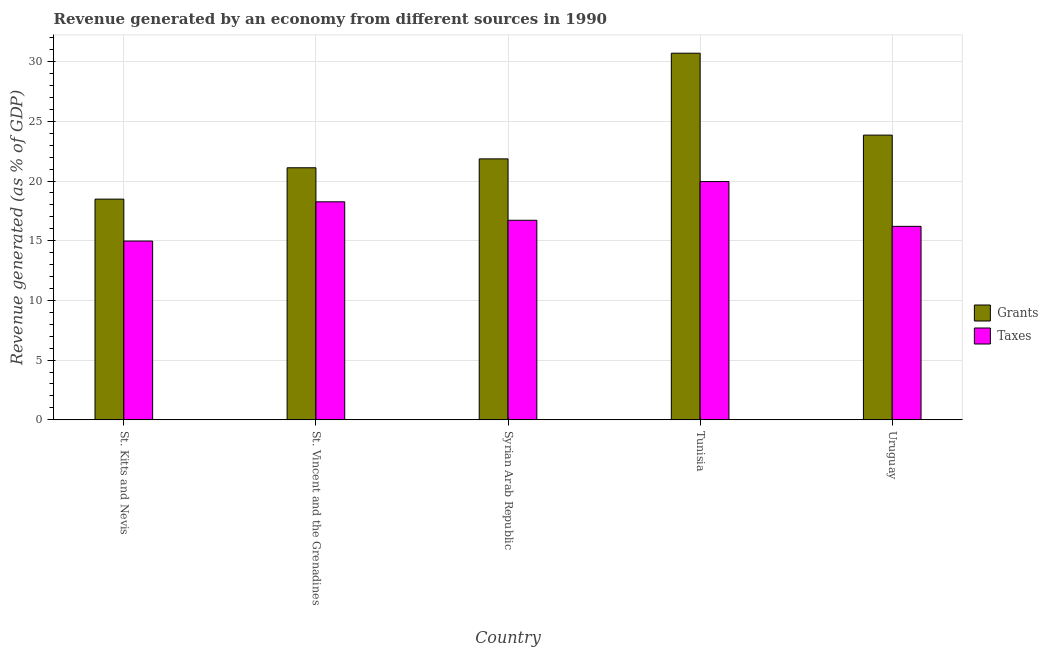How many different coloured bars are there?
Your response must be concise. 2. How many groups of bars are there?
Keep it short and to the point. 5. Are the number of bars per tick equal to the number of legend labels?
Provide a short and direct response. Yes. Are the number of bars on each tick of the X-axis equal?
Provide a short and direct response. Yes. What is the label of the 2nd group of bars from the left?
Make the answer very short. St. Vincent and the Grenadines. In how many cases, is the number of bars for a given country not equal to the number of legend labels?
Keep it short and to the point. 0. What is the revenue generated by grants in Syrian Arab Republic?
Provide a short and direct response. 21.85. Across all countries, what is the maximum revenue generated by taxes?
Provide a succinct answer. 19.95. Across all countries, what is the minimum revenue generated by grants?
Keep it short and to the point. 18.48. In which country was the revenue generated by grants maximum?
Provide a short and direct response. Tunisia. In which country was the revenue generated by taxes minimum?
Your response must be concise. St. Kitts and Nevis. What is the total revenue generated by taxes in the graph?
Provide a short and direct response. 86.1. What is the difference between the revenue generated by grants in Syrian Arab Republic and that in Uruguay?
Provide a succinct answer. -1.99. What is the difference between the revenue generated by grants in St. Vincent and the Grenadines and the revenue generated by taxes in Tunisia?
Make the answer very short. 1.16. What is the average revenue generated by taxes per country?
Make the answer very short. 17.22. What is the difference between the revenue generated by taxes and revenue generated by grants in St. Kitts and Nevis?
Provide a succinct answer. -3.51. What is the ratio of the revenue generated by taxes in Syrian Arab Republic to that in Uruguay?
Offer a terse response. 1.03. What is the difference between the highest and the second highest revenue generated by taxes?
Provide a short and direct response. 1.69. What is the difference between the highest and the lowest revenue generated by taxes?
Offer a terse response. 4.98. In how many countries, is the revenue generated by grants greater than the average revenue generated by grants taken over all countries?
Give a very brief answer. 2. Is the sum of the revenue generated by grants in Syrian Arab Republic and Tunisia greater than the maximum revenue generated by taxes across all countries?
Offer a terse response. Yes. What does the 2nd bar from the left in Uruguay represents?
Offer a terse response. Taxes. What does the 1st bar from the right in St. Kitts and Nevis represents?
Give a very brief answer. Taxes. How many bars are there?
Offer a very short reply. 10. Are all the bars in the graph horizontal?
Keep it short and to the point. No. How many countries are there in the graph?
Keep it short and to the point. 5. What is the difference between two consecutive major ticks on the Y-axis?
Provide a short and direct response. 5. Where does the legend appear in the graph?
Make the answer very short. Center right. How many legend labels are there?
Keep it short and to the point. 2. How are the legend labels stacked?
Keep it short and to the point. Vertical. What is the title of the graph?
Your answer should be compact. Revenue generated by an economy from different sources in 1990. What is the label or title of the X-axis?
Offer a terse response. Country. What is the label or title of the Y-axis?
Offer a terse response. Revenue generated (as % of GDP). What is the Revenue generated (as % of GDP) of Grants in St. Kitts and Nevis?
Your answer should be compact. 18.48. What is the Revenue generated (as % of GDP) of Taxes in St. Kitts and Nevis?
Keep it short and to the point. 14.97. What is the Revenue generated (as % of GDP) of Grants in St. Vincent and the Grenadines?
Keep it short and to the point. 21.11. What is the Revenue generated (as % of GDP) in Taxes in St. Vincent and the Grenadines?
Your answer should be very brief. 18.26. What is the Revenue generated (as % of GDP) in Grants in Syrian Arab Republic?
Provide a short and direct response. 21.85. What is the Revenue generated (as % of GDP) of Taxes in Syrian Arab Republic?
Your response must be concise. 16.71. What is the Revenue generated (as % of GDP) in Grants in Tunisia?
Provide a succinct answer. 30.71. What is the Revenue generated (as % of GDP) in Taxes in Tunisia?
Provide a succinct answer. 19.95. What is the Revenue generated (as % of GDP) of Grants in Uruguay?
Make the answer very short. 23.84. What is the Revenue generated (as % of GDP) in Taxes in Uruguay?
Your answer should be compact. 16.2. Across all countries, what is the maximum Revenue generated (as % of GDP) of Grants?
Your response must be concise. 30.71. Across all countries, what is the maximum Revenue generated (as % of GDP) of Taxes?
Provide a short and direct response. 19.95. Across all countries, what is the minimum Revenue generated (as % of GDP) of Grants?
Your answer should be very brief. 18.48. Across all countries, what is the minimum Revenue generated (as % of GDP) in Taxes?
Give a very brief answer. 14.97. What is the total Revenue generated (as % of GDP) of Grants in the graph?
Your answer should be compact. 116. What is the total Revenue generated (as % of GDP) in Taxes in the graph?
Keep it short and to the point. 86.1. What is the difference between the Revenue generated (as % of GDP) in Grants in St. Kitts and Nevis and that in St. Vincent and the Grenadines?
Give a very brief answer. -2.63. What is the difference between the Revenue generated (as % of GDP) in Taxes in St. Kitts and Nevis and that in St. Vincent and the Grenadines?
Provide a short and direct response. -3.29. What is the difference between the Revenue generated (as % of GDP) in Grants in St. Kitts and Nevis and that in Syrian Arab Republic?
Your answer should be very brief. -3.37. What is the difference between the Revenue generated (as % of GDP) in Taxes in St. Kitts and Nevis and that in Syrian Arab Republic?
Make the answer very short. -1.74. What is the difference between the Revenue generated (as % of GDP) in Grants in St. Kitts and Nevis and that in Tunisia?
Your answer should be very brief. -12.22. What is the difference between the Revenue generated (as % of GDP) of Taxes in St. Kitts and Nevis and that in Tunisia?
Your answer should be very brief. -4.98. What is the difference between the Revenue generated (as % of GDP) in Grants in St. Kitts and Nevis and that in Uruguay?
Your answer should be compact. -5.36. What is the difference between the Revenue generated (as % of GDP) in Taxes in St. Kitts and Nevis and that in Uruguay?
Your response must be concise. -1.23. What is the difference between the Revenue generated (as % of GDP) of Grants in St. Vincent and the Grenadines and that in Syrian Arab Republic?
Make the answer very short. -0.74. What is the difference between the Revenue generated (as % of GDP) of Taxes in St. Vincent and the Grenadines and that in Syrian Arab Republic?
Ensure brevity in your answer.  1.55. What is the difference between the Revenue generated (as % of GDP) of Grants in St. Vincent and the Grenadines and that in Tunisia?
Give a very brief answer. -9.6. What is the difference between the Revenue generated (as % of GDP) of Taxes in St. Vincent and the Grenadines and that in Tunisia?
Offer a terse response. -1.69. What is the difference between the Revenue generated (as % of GDP) of Grants in St. Vincent and the Grenadines and that in Uruguay?
Ensure brevity in your answer.  -2.73. What is the difference between the Revenue generated (as % of GDP) of Taxes in St. Vincent and the Grenadines and that in Uruguay?
Your answer should be very brief. 2.06. What is the difference between the Revenue generated (as % of GDP) in Grants in Syrian Arab Republic and that in Tunisia?
Make the answer very short. -8.85. What is the difference between the Revenue generated (as % of GDP) in Taxes in Syrian Arab Republic and that in Tunisia?
Make the answer very short. -3.24. What is the difference between the Revenue generated (as % of GDP) of Grants in Syrian Arab Republic and that in Uruguay?
Offer a very short reply. -1.99. What is the difference between the Revenue generated (as % of GDP) in Taxes in Syrian Arab Republic and that in Uruguay?
Your answer should be very brief. 0.51. What is the difference between the Revenue generated (as % of GDP) in Grants in Tunisia and that in Uruguay?
Your answer should be very brief. 6.86. What is the difference between the Revenue generated (as % of GDP) of Taxes in Tunisia and that in Uruguay?
Your response must be concise. 3.75. What is the difference between the Revenue generated (as % of GDP) of Grants in St. Kitts and Nevis and the Revenue generated (as % of GDP) of Taxes in St. Vincent and the Grenadines?
Offer a very short reply. 0.22. What is the difference between the Revenue generated (as % of GDP) of Grants in St. Kitts and Nevis and the Revenue generated (as % of GDP) of Taxes in Syrian Arab Republic?
Give a very brief answer. 1.77. What is the difference between the Revenue generated (as % of GDP) of Grants in St. Kitts and Nevis and the Revenue generated (as % of GDP) of Taxes in Tunisia?
Your response must be concise. -1.47. What is the difference between the Revenue generated (as % of GDP) in Grants in St. Kitts and Nevis and the Revenue generated (as % of GDP) in Taxes in Uruguay?
Keep it short and to the point. 2.28. What is the difference between the Revenue generated (as % of GDP) of Grants in St. Vincent and the Grenadines and the Revenue generated (as % of GDP) of Taxes in Syrian Arab Republic?
Offer a terse response. 4.4. What is the difference between the Revenue generated (as % of GDP) of Grants in St. Vincent and the Grenadines and the Revenue generated (as % of GDP) of Taxes in Tunisia?
Your answer should be very brief. 1.16. What is the difference between the Revenue generated (as % of GDP) of Grants in St. Vincent and the Grenadines and the Revenue generated (as % of GDP) of Taxes in Uruguay?
Your answer should be very brief. 4.91. What is the difference between the Revenue generated (as % of GDP) of Grants in Syrian Arab Republic and the Revenue generated (as % of GDP) of Taxes in Tunisia?
Offer a very short reply. 1.9. What is the difference between the Revenue generated (as % of GDP) of Grants in Syrian Arab Republic and the Revenue generated (as % of GDP) of Taxes in Uruguay?
Provide a succinct answer. 5.65. What is the difference between the Revenue generated (as % of GDP) of Grants in Tunisia and the Revenue generated (as % of GDP) of Taxes in Uruguay?
Your answer should be compact. 14.5. What is the average Revenue generated (as % of GDP) in Grants per country?
Make the answer very short. 23.2. What is the average Revenue generated (as % of GDP) in Taxes per country?
Your answer should be very brief. 17.22. What is the difference between the Revenue generated (as % of GDP) in Grants and Revenue generated (as % of GDP) in Taxes in St. Kitts and Nevis?
Your answer should be very brief. 3.51. What is the difference between the Revenue generated (as % of GDP) of Grants and Revenue generated (as % of GDP) of Taxes in St. Vincent and the Grenadines?
Provide a succinct answer. 2.85. What is the difference between the Revenue generated (as % of GDP) in Grants and Revenue generated (as % of GDP) in Taxes in Syrian Arab Republic?
Your answer should be compact. 5.14. What is the difference between the Revenue generated (as % of GDP) of Grants and Revenue generated (as % of GDP) of Taxes in Tunisia?
Offer a very short reply. 10.75. What is the difference between the Revenue generated (as % of GDP) of Grants and Revenue generated (as % of GDP) of Taxes in Uruguay?
Provide a succinct answer. 7.64. What is the ratio of the Revenue generated (as % of GDP) in Grants in St. Kitts and Nevis to that in St. Vincent and the Grenadines?
Keep it short and to the point. 0.88. What is the ratio of the Revenue generated (as % of GDP) of Taxes in St. Kitts and Nevis to that in St. Vincent and the Grenadines?
Offer a terse response. 0.82. What is the ratio of the Revenue generated (as % of GDP) of Grants in St. Kitts and Nevis to that in Syrian Arab Republic?
Your answer should be compact. 0.85. What is the ratio of the Revenue generated (as % of GDP) of Taxes in St. Kitts and Nevis to that in Syrian Arab Republic?
Offer a very short reply. 0.9. What is the ratio of the Revenue generated (as % of GDP) of Grants in St. Kitts and Nevis to that in Tunisia?
Provide a succinct answer. 0.6. What is the ratio of the Revenue generated (as % of GDP) of Taxes in St. Kitts and Nevis to that in Tunisia?
Provide a short and direct response. 0.75. What is the ratio of the Revenue generated (as % of GDP) in Grants in St. Kitts and Nevis to that in Uruguay?
Your answer should be very brief. 0.78. What is the ratio of the Revenue generated (as % of GDP) of Taxes in St. Kitts and Nevis to that in Uruguay?
Keep it short and to the point. 0.92. What is the ratio of the Revenue generated (as % of GDP) in Taxes in St. Vincent and the Grenadines to that in Syrian Arab Republic?
Offer a very short reply. 1.09. What is the ratio of the Revenue generated (as % of GDP) in Grants in St. Vincent and the Grenadines to that in Tunisia?
Keep it short and to the point. 0.69. What is the ratio of the Revenue generated (as % of GDP) in Taxes in St. Vincent and the Grenadines to that in Tunisia?
Offer a very short reply. 0.92. What is the ratio of the Revenue generated (as % of GDP) in Grants in St. Vincent and the Grenadines to that in Uruguay?
Keep it short and to the point. 0.89. What is the ratio of the Revenue generated (as % of GDP) of Taxes in St. Vincent and the Grenadines to that in Uruguay?
Offer a very short reply. 1.13. What is the ratio of the Revenue generated (as % of GDP) in Grants in Syrian Arab Republic to that in Tunisia?
Make the answer very short. 0.71. What is the ratio of the Revenue generated (as % of GDP) of Taxes in Syrian Arab Republic to that in Tunisia?
Your response must be concise. 0.84. What is the ratio of the Revenue generated (as % of GDP) of Grants in Syrian Arab Republic to that in Uruguay?
Provide a succinct answer. 0.92. What is the ratio of the Revenue generated (as % of GDP) of Taxes in Syrian Arab Republic to that in Uruguay?
Provide a succinct answer. 1.03. What is the ratio of the Revenue generated (as % of GDP) in Grants in Tunisia to that in Uruguay?
Your answer should be very brief. 1.29. What is the ratio of the Revenue generated (as % of GDP) in Taxes in Tunisia to that in Uruguay?
Offer a terse response. 1.23. What is the difference between the highest and the second highest Revenue generated (as % of GDP) in Grants?
Your answer should be compact. 6.86. What is the difference between the highest and the second highest Revenue generated (as % of GDP) of Taxes?
Your answer should be very brief. 1.69. What is the difference between the highest and the lowest Revenue generated (as % of GDP) in Grants?
Provide a short and direct response. 12.22. What is the difference between the highest and the lowest Revenue generated (as % of GDP) in Taxes?
Your answer should be very brief. 4.98. 